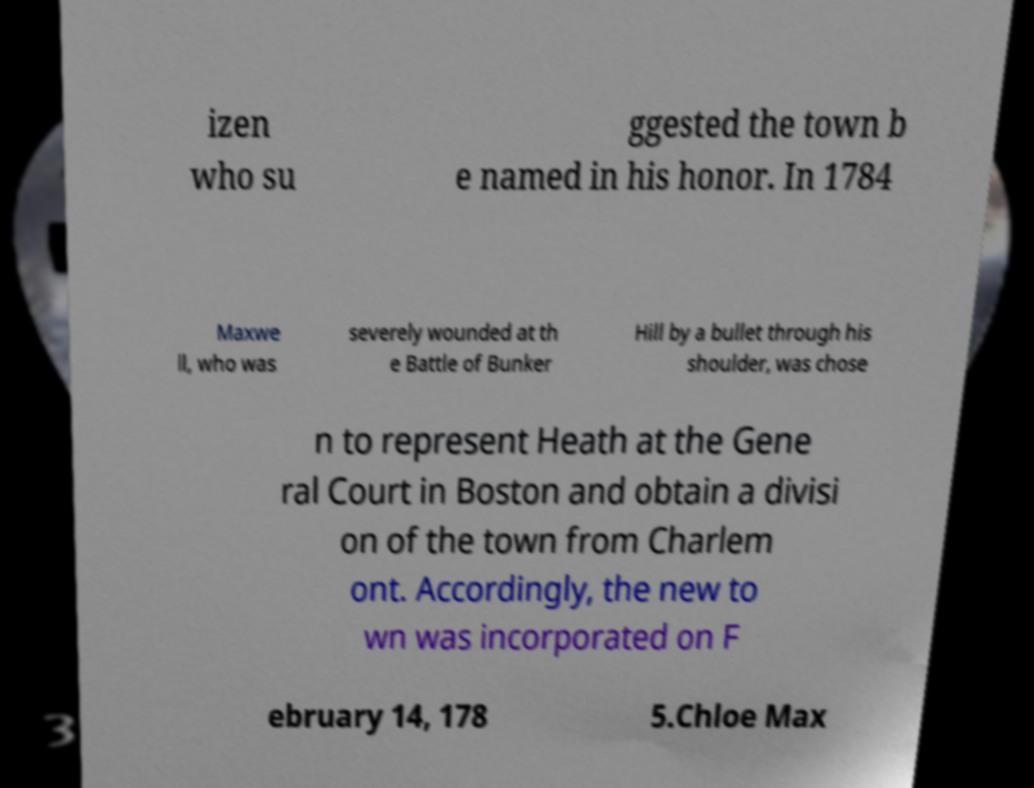There's text embedded in this image that I need extracted. Can you transcribe it verbatim? izen who su ggested the town b e named in his honor. In 1784 Maxwe ll, who was severely wounded at th e Battle of Bunker Hill by a bullet through his shoulder, was chose n to represent Heath at the Gene ral Court in Boston and obtain a divisi on of the town from Charlem ont. Accordingly, the new to wn was incorporated on F ebruary 14, 178 5.Chloe Max 